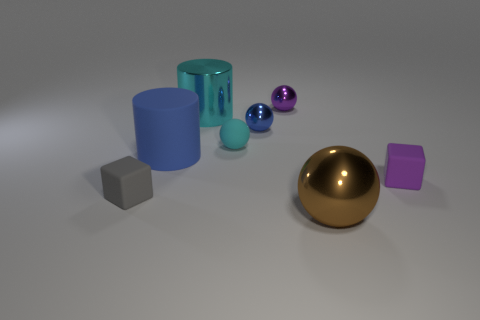How many small shiny objects have the same color as the matte cylinder?
Provide a succinct answer. 1. What is the size of the matte object that is both in front of the blue matte cylinder and left of the rubber sphere?
Provide a succinct answer. Small. Are there fewer small purple metal balls that are to the left of the tiny gray cube than small purple metallic things?
Provide a succinct answer. Yes. Are the large sphere and the gray object made of the same material?
Your answer should be very brief. No. How many things are tiny purple cubes or big cyan cylinders?
Provide a short and direct response. 2. How many big blue things are made of the same material as the large cyan cylinder?
Your answer should be compact. 0. What size is the gray thing that is the same shape as the purple rubber thing?
Ensure brevity in your answer.  Small. There is a big cyan metallic thing; are there any blue rubber things to the right of it?
Your answer should be very brief. No. What material is the tiny blue sphere?
Make the answer very short. Metal. Is the color of the large object right of the metallic cylinder the same as the big metallic cylinder?
Your response must be concise. No. 